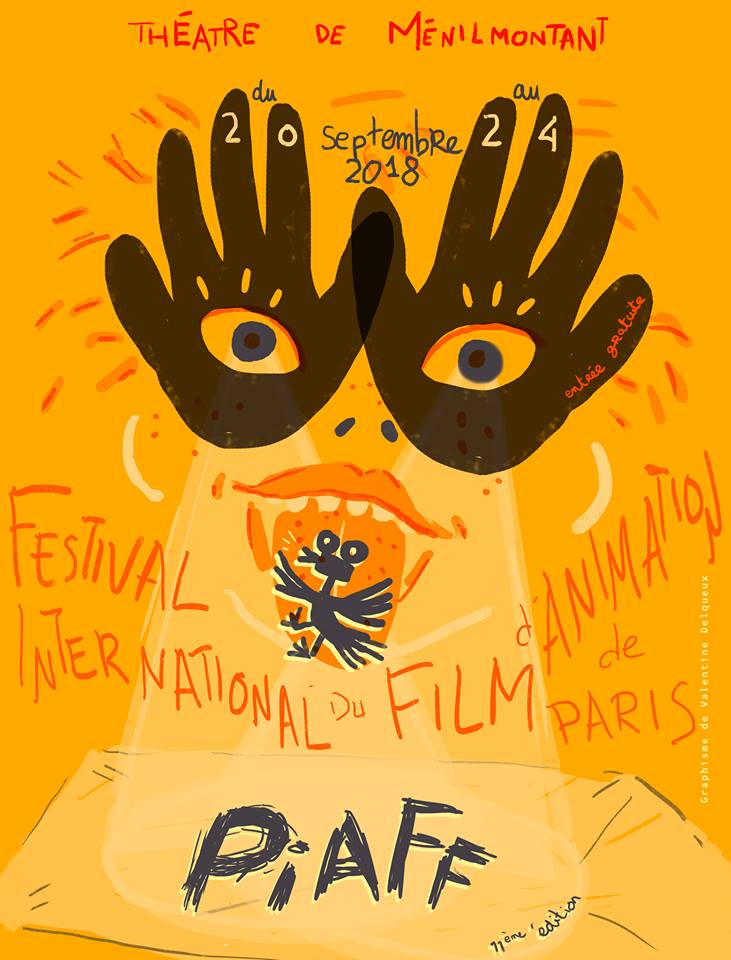What can you infer about the target audience based on this poster? The target audience for this poster appears to be individuals who appreciate creative and artistic events, likely including fans of animation, filmmakers, artists, and graphic designers. The whimsical and vibrant design appeals to those who are drawn to imaginative and visually stimulating experiences. The use of hand-drawn elements and bold, playful typography suggests an audience that values artistic expression and creativity. Moreover, the focus on animation indicates an appeal to both children and adults with a fondness for animated films and storytelling. 